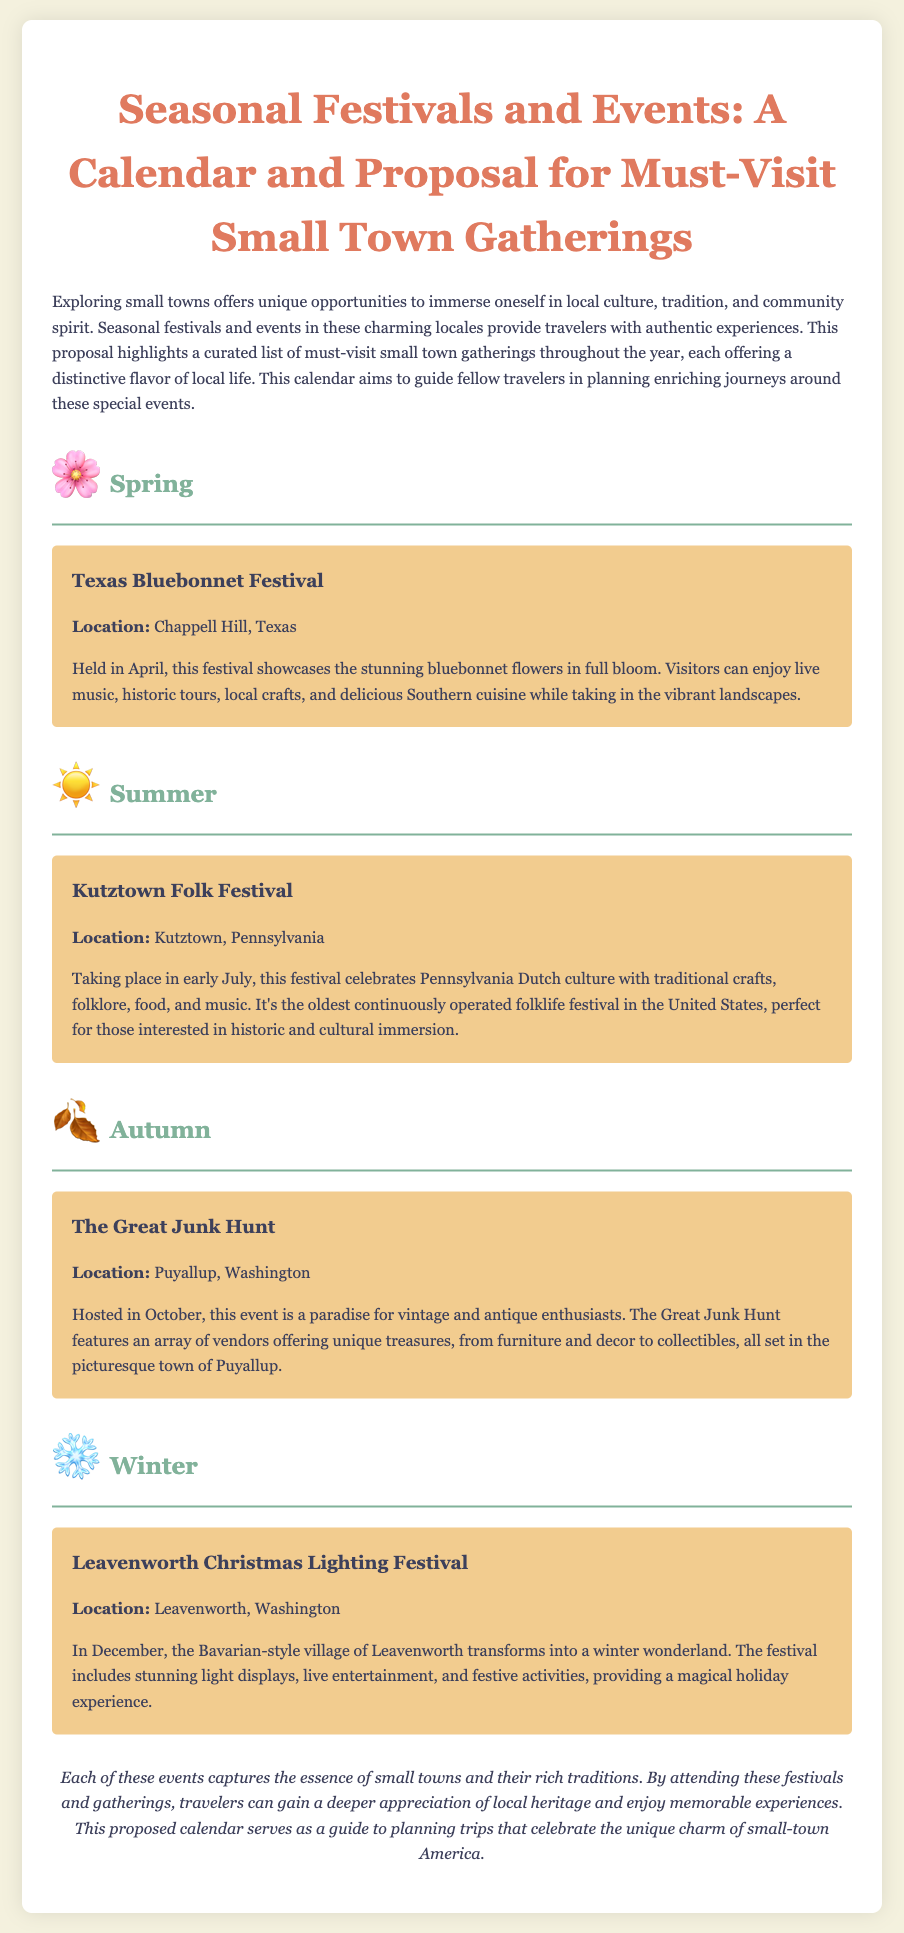What is the title of the proposal? The title of the proposal is found at the top of the document.
Answer: Seasonal Festivals and Events: A Calendar and Proposal for Must-Visit Small Town Gatherings Where is the Texas Bluebonnet Festival held? The location of the Texas Bluebonnet Festival is mentioned in the description of the event.
Answer: Chappell Hill, Texas When does the Kutztown Folk Festival take place? The specific month of the Kutztown Folk Festival is indicated in the document.
Answer: July What type of culture does the Kutztown Folk Festival celebrate? The type of culture celebrated at the Kutztown Folk Festival is stated in the event's description.
Answer: Pennsylvania Dutch culture Which season features The Great Junk Hunt? The season is indicated through the section headers in the document.
Answer: Autumn What is the main focus of the proposal? The main focus is outlined in the introductory paragraph of the document.
Answer: Must-visit small town gatherings What kind of activities are included in the Leavenworth Christmas Lighting Festival? The types of activities are specifically listed in the event description.
Answer: Light displays, live entertainment, and festive activities Why might a traveler want to attend these festivals? The conclusion provides insight into the reasons for attending the festivals.
Answer: Gain a deeper appreciation of local heritage Which state hosts the Leavenworth Christmas Lighting Festival? The state where the festival occurs is explicitly mentioned in the event description.
Answer: Washington 